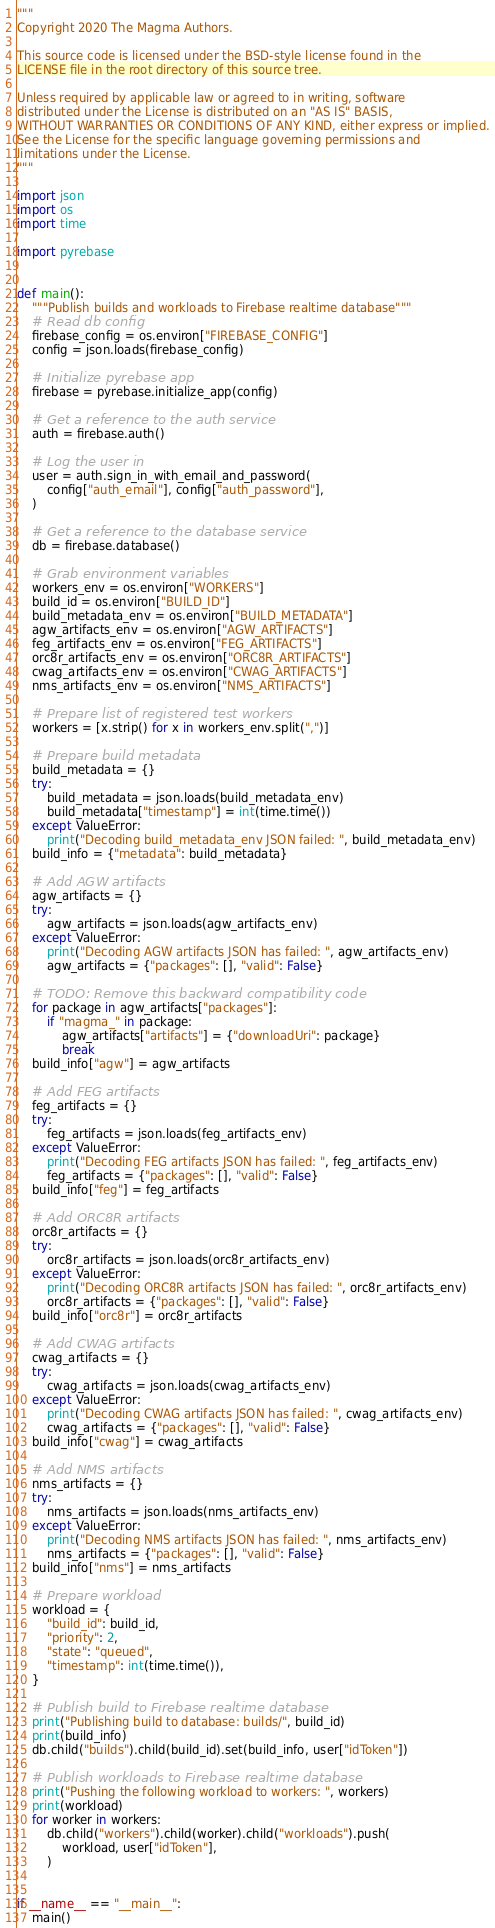<code> <loc_0><loc_0><loc_500><loc_500><_Python_>"""
Copyright 2020 The Magma Authors.

This source code is licensed under the BSD-style license found in the
LICENSE file in the root directory of this source tree.

Unless required by applicable law or agreed to in writing, software
distributed under the License is distributed on an "AS IS" BASIS,
WITHOUT WARRANTIES OR CONDITIONS OF ANY KIND, either express or implied.
See the License for the specific language governing permissions and
limitations under the License.
"""

import json
import os
import time

import pyrebase


def main():
    """Publish builds and workloads to Firebase realtime database"""
    # Read db config
    firebase_config = os.environ["FIREBASE_CONFIG"]
    config = json.loads(firebase_config)

    # Initialize pyrebase app
    firebase = pyrebase.initialize_app(config)

    # Get a reference to the auth service
    auth = firebase.auth()

    # Log the user in
    user = auth.sign_in_with_email_and_password(
        config["auth_email"], config["auth_password"],
    )

    # Get a reference to the database service
    db = firebase.database()

    # Grab environment variables
    workers_env = os.environ["WORKERS"]
    build_id = os.environ["BUILD_ID"]
    build_metadata_env = os.environ["BUILD_METADATA"]
    agw_artifacts_env = os.environ["AGW_ARTIFACTS"]
    feg_artifacts_env = os.environ["FEG_ARTIFACTS"]
    orc8r_artifacts_env = os.environ["ORC8R_ARTIFACTS"]
    cwag_artifacts_env = os.environ["CWAG_ARTIFACTS"]
    nms_artifacts_env = os.environ["NMS_ARTIFACTS"]

    # Prepare list of registered test workers
    workers = [x.strip() for x in workers_env.split(",")]

    # Prepare build metadata
    build_metadata = {}
    try:
        build_metadata = json.loads(build_metadata_env)
        build_metadata["timestamp"] = int(time.time())
    except ValueError:
        print("Decoding build_metadata_env JSON failed: ", build_metadata_env)
    build_info = {"metadata": build_metadata}

    # Add AGW artifacts
    agw_artifacts = {}
    try:
        agw_artifacts = json.loads(agw_artifacts_env)
    except ValueError:
        print("Decoding AGW artifacts JSON has failed: ", agw_artifacts_env)
        agw_artifacts = {"packages": [], "valid": False}

    # TODO: Remove this backward compatibility code
    for package in agw_artifacts["packages"]:
        if "magma_" in package:
            agw_artifacts["artifacts"] = {"downloadUri": package}
            break
    build_info["agw"] = agw_artifacts

    # Add FEG artifacts
    feg_artifacts = {}
    try:
        feg_artifacts = json.loads(feg_artifacts_env)
    except ValueError:
        print("Decoding FEG artifacts JSON has failed: ", feg_artifacts_env)
        feg_artifacts = {"packages": [], "valid": False}
    build_info["feg"] = feg_artifacts

    # Add ORC8R artifacts
    orc8r_artifacts = {}
    try:
        orc8r_artifacts = json.loads(orc8r_artifacts_env)
    except ValueError:
        print("Decoding ORC8R artifacts JSON has failed: ", orc8r_artifacts_env)
        orc8r_artifacts = {"packages": [], "valid": False}
    build_info["orc8r"] = orc8r_artifacts

    # Add CWAG artifacts
    cwag_artifacts = {}
    try:
        cwag_artifacts = json.loads(cwag_artifacts_env)
    except ValueError:
        print("Decoding CWAG artifacts JSON has failed: ", cwag_artifacts_env)
        cwag_artifacts = {"packages": [], "valid": False}
    build_info["cwag"] = cwag_artifacts

    # Add NMS artifacts
    nms_artifacts = {}
    try:
        nms_artifacts = json.loads(nms_artifacts_env)
    except ValueError:
        print("Decoding NMS artifacts JSON has failed: ", nms_artifacts_env)
        nms_artifacts = {"packages": [], "valid": False}
    build_info["nms"] = nms_artifacts

    # Prepare workload
    workload = {
        "build_id": build_id,
        "priority": 2,
        "state": "queued",
        "timestamp": int(time.time()),
    }

    # Publish build to Firebase realtime database
    print("Publishing build to database: builds/", build_id)
    print(build_info)
    db.child("builds").child(build_id).set(build_info, user["idToken"])

    # Publish workloads to Firebase realtime database
    print("Pushing the following workload to workers: ", workers)
    print(workload)
    for worker in workers:
        db.child("workers").child(worker).child("workloads").push(
            workload, user["idToken"],
        )


if __name__ == "__main__":
    main()
</code> 